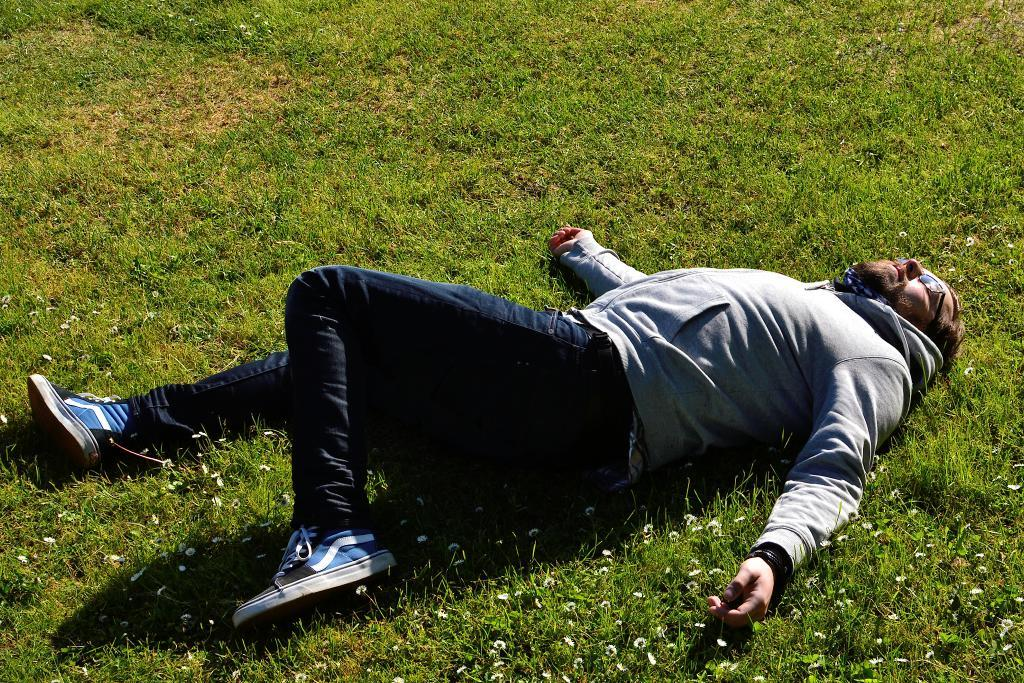What is the main subject in the center of the image? There is a person lying in the center of the image. What type of surface is visible at the bottom of the image? There is grass at the bottom of the image. What type of beam can be seen supporting the person in the image? There is no beam present in the image; the person is lying on the grass. What type of corn is growing in the grass at the bottom of the image? There is no corn present in the image; only grass is visible. 